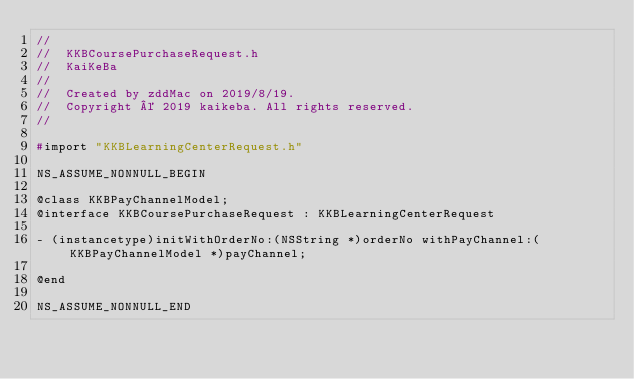<code> <loc_0><loc_0><loc_500><loc_500><_C_>//
//  KKBCoursePurchaseRequest.h
//  KaiKeBa
//
//  Created by zddMac on 2019/8/19.
//  Copyright © 2019 kaikeba. All rights reserved.
//

#import "KKBLearningCenterRequest.h"

NS_ASSUME_NONNULL_BEGIN

@class KKBPayChannelModel;
@interface KKBCoursePurchaseRequest : KKBLearningCenterRequest

- (instancetype)initWithOrderNo:(NSString *)orderNo withPayChannel:(KKBPayChannelModel *)payChannel;

@end

NS_ASSUME_NONNULL_END
</code> 